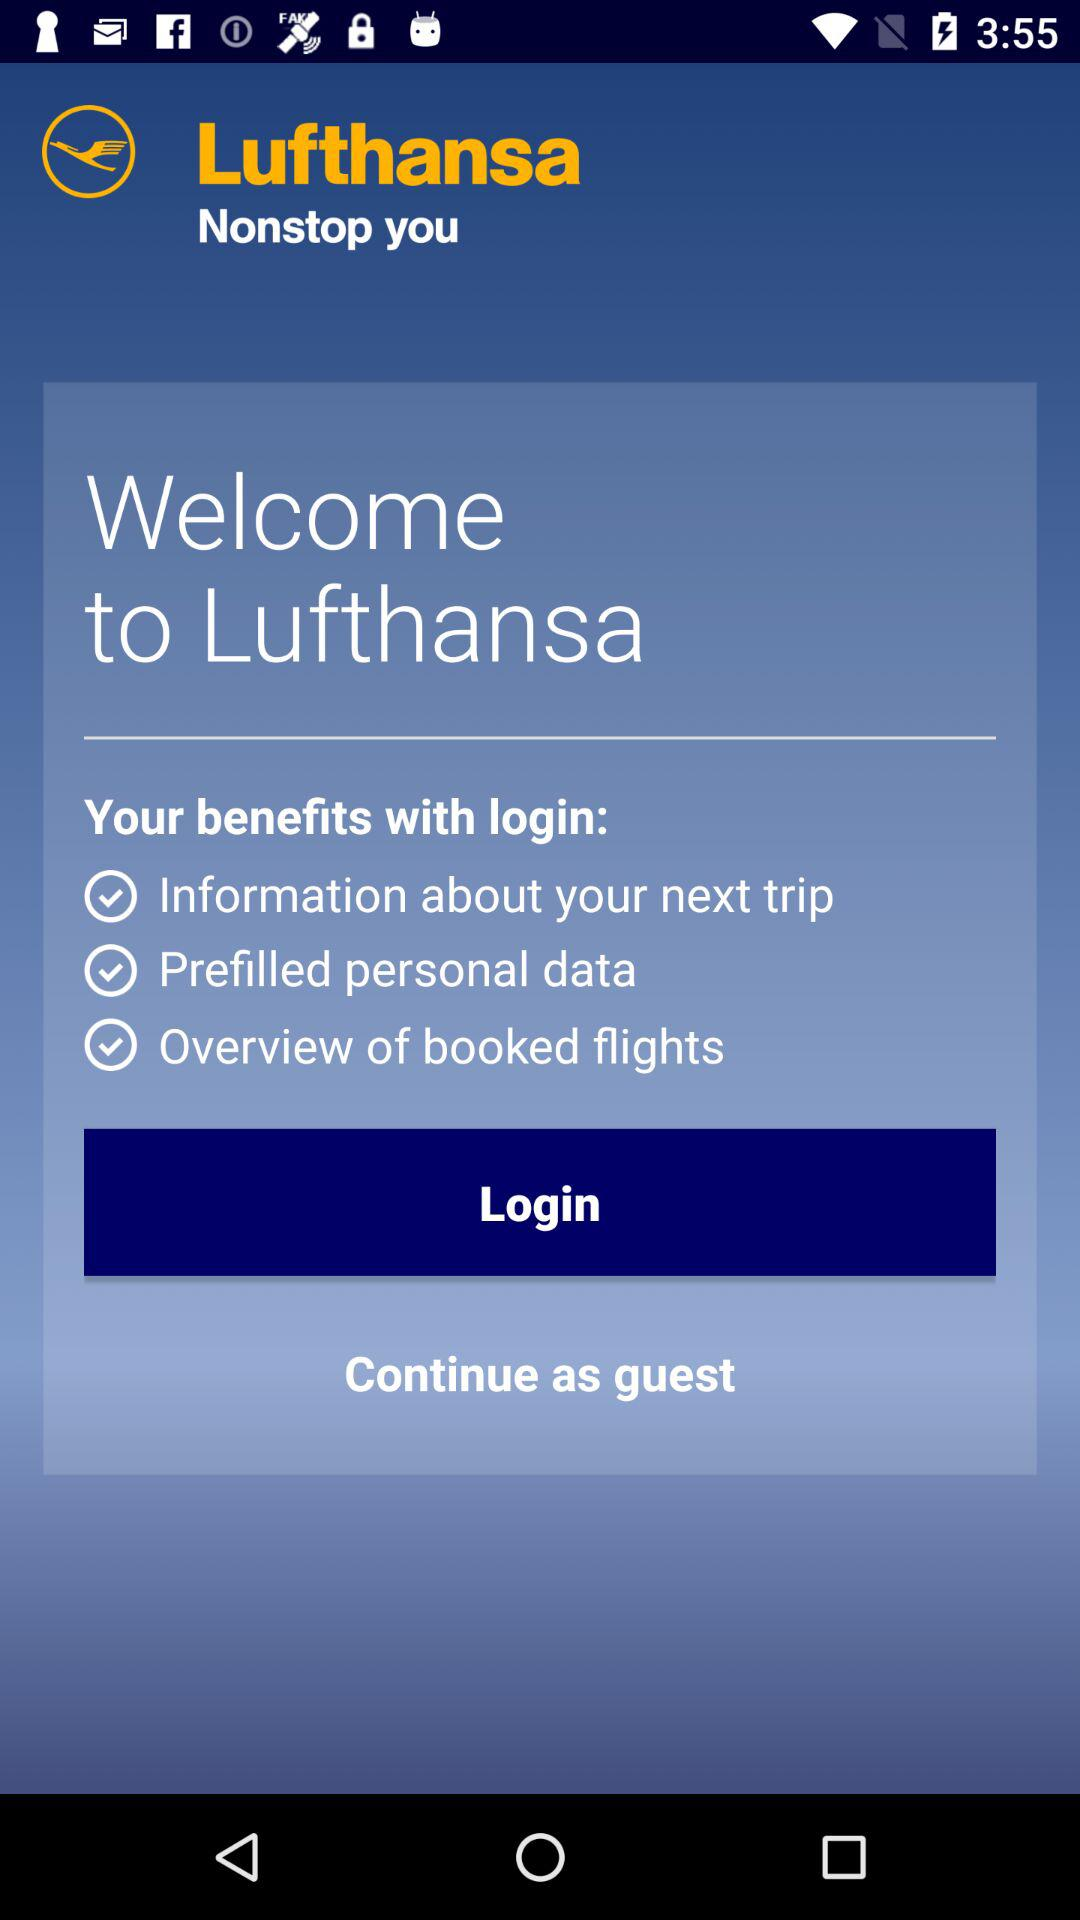How many benefits does Lufthansa provide to users who login?
Answer the question using a single word or phrase. 3 